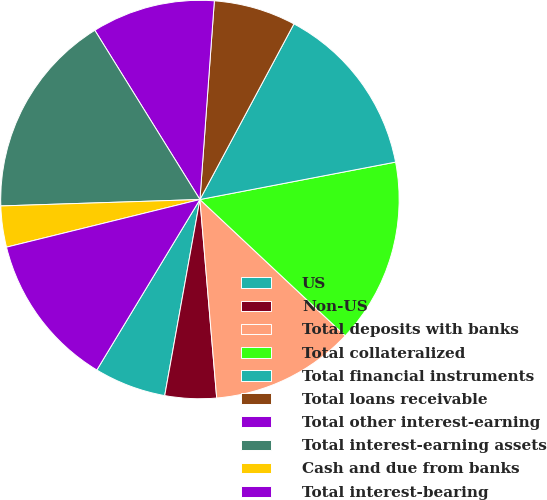<chart> <loc_0><loc_0><loc_500><loc_500><pie_chart><fcel>US<fcel>Non-US<fcel>Total deposits with banks<fcel>Total collateralized<fcel>Total financial instruments<fcel>Total loans receivable<fcel>Total other interest-earning<fcel>Total interest-earning assets<fcel>Cash and due from banks<fcel>Total interest-bearing<nl><fcel>5.83%<fcel>4.17%<fcel>11.67%<fcel>15.0%<fcel>14.17%<fcel>6.67%<fcel>10.0%<fcel>16.67%<fcel>3.33%<fcel>12.5%<nl></chart> 